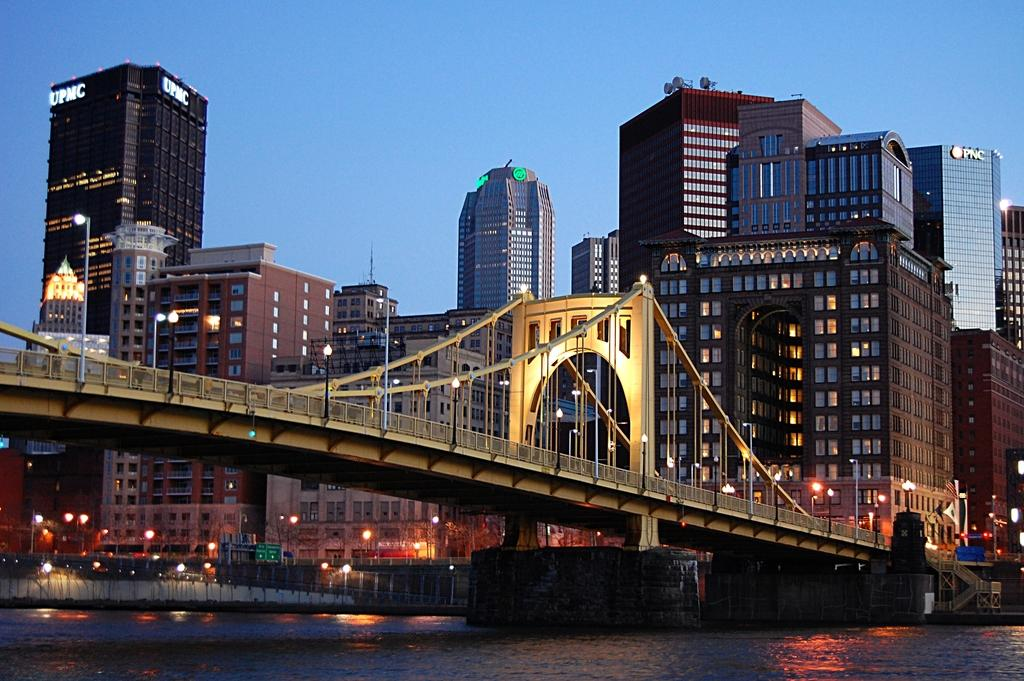What type of structure can be seen in the image? There is a bridge in the image. What are the light poles used for in the image? The light poles provide illumination in the image. What type of structures are visible in the background? There are buildings in the image, and their windows are visible. What natural element is present in the image? There is water in the image. What is the color of the sky in the image? The sky is pale blue in color. What type of jar is being used to support the bridge in the image? There is no jar present in the image, and the bridge is supported by its own structure. Can you see the stomach of the person walking on the bridge in the image? There is no person walking on the bridge in the image, so it is not possible to see their stomach. 